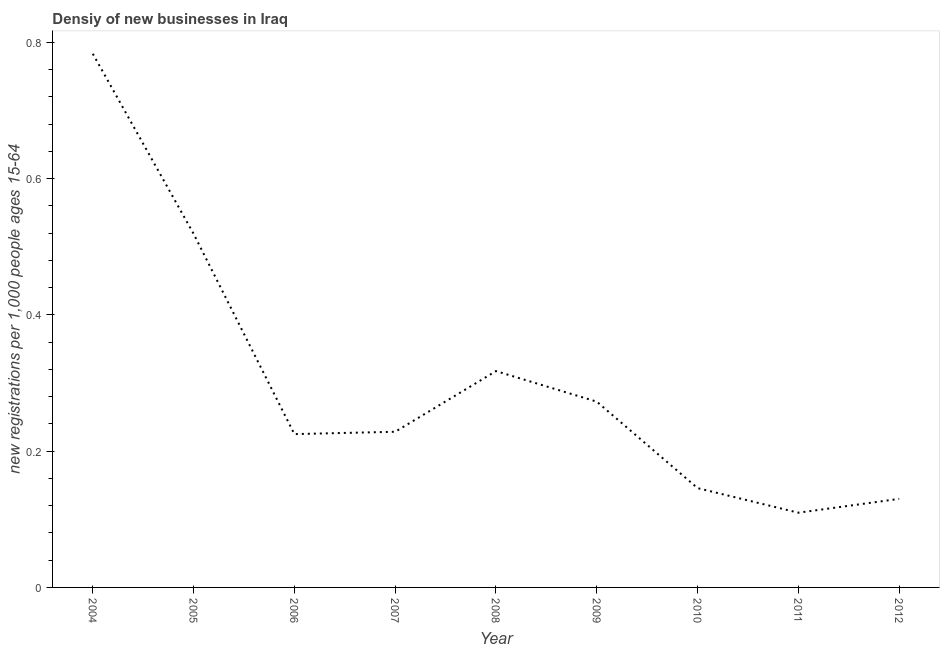What is the density of new business in 2008?
Offer a terse response. 0.32. Across all years, what is the maximum density of new business?
Provide a short and direct response. 0.78. Across all years, what is the minimum density of new business?
Your response must be concise. 0.11. In which year was the density of new business maximum?
Offer a terse response. 2004. What is the sum of the density of new business?
Your response must be concise. 2.73. What is the difference between the density of new business in 2004 and 2010?
Provide a short and direct response. 0.64. What is the average density of new business per year?
Offer a terse response. 0.3. What is the median density of new business?
Keep it short and to the point. 0.23. In how many years, is the density of new business greater than 0.4 ?
Your answer should be very brief. 2. Do a majority of the years between 2004 and 2007 (inclusive) have density of new business greater than 0.44 ?
Provide a succinct answer. No. What is the ratio of the density of new business in 2004 to that in 2005?
Offer a terse response. 1.51. Is the difference between the density of new business in 2005 and 2012 greater than the difference between any two years?
Offer a very short reply. No. What is the difference between the highest and the second highest density of new business?
Ensure brevity in your answer.  0.26. What is the difference between the highest and the lowest density of new business?
Keep it short and to the point. 0.67. In how many years, is the density of new business greater than the average density of new business taken over all years?
Give a very brief answer. 3. How many lines are there?
Your answer should be compact. 1. Are the values on the major ticks of Y-axis written in scientific E-notation?
Your answer should be compact. No. Does the graph contain any zero values?
Ensure brevity in your answer.  No. Does the graph contain grids?
Keep it short and to the point. No. What is the title of the graph?
Ensure brevity in your answer.  Densiy of new businesses in Iraq. What is the label or title of the Y-axis?
Ensure brevity in your answer.  New registrations per 1,0 people ages 15-64. What is the new registrations per 1,000 people ages 15-64 of 2004?
Your answer should be very brief. 0.78. What is the new registrations per 1,000 people ages 15-64 of 2005?
Give a very brief answer. 0.52. What is the new registrations per 1,000 people ages 15-64 of 2006?
Make the answer very short. 0.23. What is the new registrations per 1,000 people ages 15-64 in 2007?
Ensure brevity in your answer.  0.23. What is the new registrations per 1,000 people ages 15-64 of 2008?
Your response must be concise. 0.32. What is the new registrations per 1,000 people ages 15-64 of 2009?
Offer a terse response. 0.27. What is the new registrations per 1,000 people ages 15-64 of 2010?
Your response must be concise. 0.15. What is the new registrations per 1,000 people ages 15-64 of 2011?
Provide a short and direct response. 0.11. What is the new registrations per 1,000 people ages 15-64 of 2012?
Provide a short and direct response. 0.13. What is the difference between the new registrations per 1,000 people ages 15-64 in 2004 and 2005?
Make the answer very short. 0.26. What is the difference between the new registrations per 1,000 people ages 15-64 in 2004 and 2006?
Your answer should be compact. 0.56. What is the difference between the new registrations per 1,000 people ages 15-64 in 2004 and 2007?
Provide a succinct answer. 0.55. What is the difference between the new registrations per 1,000 people ages 15-64 in 2004 and 2008?
Your answer should be compact. 0.47. What is the difference between the new registrations per 1,000 people ages 15-64 in 2004 and 2009?
Your response must be concise. 0.51. What is the difference between the new registrations per 1,000 people ages 15-64 in 2004 and 2010?
Provide a succinct answer. 0.64. What is the difference between the new registrations per 1,000 people ages 15-64 in 2004 and 2011?
Provide a short and direct response. 0.67. What is the difference between the new registrations per 1,000 people ages 15-64 in 2004 and 2012?
Give a very brief answer. 0.65. What is the difference between the new registrations per 1,000 people ages 15-64 in 2005 and 2006?
Your answer should be very brief. 0.29. What is the difference between the new registrations per 1,000 people ages 15-64 in 2005 and 2007?
Ensure brevity in your answer.  0.29. What is the difference between the new registrations per 1,000 people ages 15-64 in 2005 and 2008?
Keep it short and to the point. 0.2. What is the difference between the new registrations per 1,000 people ages 15-64 in 2005 and 2009?
Ensure brevity in your answer.  0.25. What is the difference between the new registrations per 1,000 people ages 15-64 in 2005 and 2010?
Keep it short and to the point. 0.37. What is the difference between the new registrations per 1,000 people ages 15-64 in 2005 and 2011?
Make the answer very short. 0.41. What is the difference between the new registrations per 1,000 people ages 15-64 in 2005 and 2012?
Provide a succinct answer. 0.39. What is the difference between the new registrations per 1,000 people ages 15-64 in 2006 and 2007?
Offer a very short reply. -0. What is the difference between the new registrations per 1,000 people ages 15-64 in 2006 and 2008?
Your response must be concise. -0.09. What is the difference between the new registrations per 1,000 people ages 15-64 in 2006 and 2009?
Provide a short and direct response. -0.05. What is the difference between the new registrations per 1,000 people ages 15-64 in 2006 and 2010?
Ensure brevity in your answer.  0.08. What is the difference between the new registrations per 1,000 people ages 15-64 in 2006 and 2011?
Ensure brevity in your answer.  0.12. What is the difference between the new registrations per 1,000 people ages 15-64 in 2006 and 2012?
Give a very brief answer. 0.1. What is the difference between the new registrations per 1,000 people ages 15-64 in 2007 and 2008?
Your answer should be compact. -0.09. What is the difference between the new registrations per 1,000 people ages 15-64 in 2007 and 2009?
Your answer should be very brief. -0.04. What is the difference between the new registrations per 1,000 people ages 15-64 in 2007 and 2010?
Your response must be concise. 0.08. What is the difference between the new registrations per 1,000 people ages 15-64 in 2007 and 2011?
Ensure brevity in your answer.  0.12. What is the difference between the new registrations per 1,000 people ages 15-64 in 2007 and 2012?
Offer a terse response. 0.1. What is the difference between the new registrations per 1,000 people ages 15-64 in 2008 and 2009?
Provide a succinct answer. 0.04. What is the difference between the new registrations per 1,000 people ages 15-64 in 2008 and 2010?
Make the answer very short. 0.17. What is the difference between the new registrations per 1,000 people ages 15-64 in 2008 and 2011?
Ensure brevity in your answer.  0.21. What is the difference between the new registrations per 1,000 people ages 15-64 in 2008 and 2012?
Your response must be concise. 0.19. What is the difference between the new registrations per 1,000 people ages 15-64 in 2009 and 2010?
Your response must be concise. 0.13. What is the difference between the new registrations per 1,000 people ages 15-64 in 2009 and 2011?
Provide a short and direct response. 0.16. What is the difference between the new registrations per 1,000 people ages 15-64 in 2009 and 2012?
Give a very brief answer. 0.14. What is the difference between the new registrations per 1,000 people ages 15-64 in 2010 and 2011?
Offer a terse response. 0.04. What is the difference between the new registrations per 1,000 people ages 15-64 in 2010 and 2012?
Ensure brevity in your answer.  0.02. What is the difference between the new registrations per 1,000 people ages 15-64 in 2011 and 2012?
Keep it short and to the point. -0.02. What is the ratio of the new registrations per 1,000 people ages 15-64 in 2004 to that in 2005?
Your response must be concise. 1.51. What is the ratio of the new registrations per 1,000 people ages 15-64 in 2004 to that in 2006?
Make the answer very short. 3.48. What is the ratio of the new registrations per 1,000 people ages 15-64 in 2004 to that in 2007?
Your answer should be very brief. 3.43. What is the ratio of the new registrations per 1,000 people ages 15-64 in 2004 to that in 2008?
Give a very brief answer. 2.47. What is the ratio of the new registrations per 1,000 people ages 15-64 in 2004 to that in 2009?
Make the answer very short. 2.87. What is the ratio of the new registrations per 1,000 people ages 15-64 in 2004 to that in 2010?
Your answer should be compact. 5.38. What is the ratio of the new registrations per 1,000 people ages 15-64 in 2004 to that in 2011?
Your answer should be very brief. 7.14. What is the ratio of the new registrations per 1,000 people ages 15-64 in 2004 to that in 2012?
Keep it short and to the point. 6.03. What is the ratio of the new registrations per 1,000 people ages 15-64 in 2005 to that in 2006?
Keep it short and to the point. 2.31. What is the ratio of the new registrations per 1,000 people ages 15-64 in 2005 to that in 2007?
Give a very brief answer. 2.27. What is the ratio of the new registrations per 1,000 people ages 15-64 in 2005 to that in 2008?
Make the answer very short. 1.64. What is the ratio of the new registrations per 1,000 people ages 15-64 in 2005 to that in 2009?
Ensure brevity in your answer.  1.9. What is the ratio of the new registrations per 1,000 people ages 15-64 in 2005 to that in 2010?
Make the answer very short. 3.56. What is the ratio of the new registrations per 1,000 people ages 15-64 in 2005 to that in 2011?
Give a very brief answer. 4.73. What is the ratio of the new registrations per 1,000 people ages 15-64 in 2005 to that in 2012?
Your response must be concise. 3.99. What is the ratio of the new registrations per 1,000 people ages 15-64 in 2006 to that in 2007?
Your answer should be very brief. 0.98. What is the ratio of the new registrations per 1,000 people ages 15-64 in 2006 to that in 2008?
Your response must be concise. 0.71. What is the ratio of the new registrations per 1,000 people ages 15-64 in 2006 to that in 2009?
Your response must be concise. 0.82. What is the ratio of the new registrations per 1,000 people ages 15-64 in 2006 to that in 2010?
Your answer should be very brief. 1.54. What is the ratio of the new registrations per 1,000 people ages 15-64 in 2006 to that in 2011?
Offer a very short reply. 2.05. What is the ratio of the new registrations per 1,000 people ages 15-64 in 2006 to that in 2012?
Ensure brevity in your answer.  1.73. What is the ratio of the new registrations per 1,000 people ages 15-64 in 2007 to that in 2008?
Keep it short and to the point. 0.72. What is the ratio of the new registrations per 1,000 people ages 15-64 in 2007 to that in 2009?
Offer a very short reply. 0.84. What is the ratio of the new registrations per 1,000 people ages 15-64 in 2007 to that in 2010?
Your answer should be compact. 1.57. What is the ratio of the new registrations per 1,000 people ages 15-64 in 2007 to that in 2011?
Your answer should be compact. 2.08. What is the ratio of the new registrations per 1,000 people ages 15-64 in 2007 to that in 2012?
Ensure brevity in your answer.  1.76. What is the ratio of the new registrations per 1,000 people ages 15-64 in 2008 to that in 2009?
Keep it short and to the point. 1.16. What is the ratio of the new registrations per 1,000 people ages 15-64 in 2008 to that in 2010?
Provide a short and direct response. 2.18. What is the ratio of the new registrations per 1,000 people ages 15-64 in 2008 to that in 2011?
Give a very brief answer. 2.9. What is the ratio of the new registrations per 1,000 people ages 15-64 in 2008 to that in 2012?
Your response must be concise. 2.44. What is the ratio of the new registrations per 1,000 people ages 15-64 in 2009 to that in 2010?
Your response must be concise. 1.87. What is the ratio of the new registrations per 1,000 people ages 15-64 in 2009 to that in 2011?
Ensure brevity in your answer.  2.49. What is the ratio of the new registrations per 1,000 people ages 15-64 in 2009 to that in 2012?
Provide a short and direct response. 2.1. What is the ratio of the new registrations per 1,000 people ages 15-64 in 2010 to that in 2011?
Provide a succinct answer. 1.33. What is the ratio of the new registrations per 1,000 people ages 15-64 in 2010 to that in 2012?
Provide a succinct answer. 1.12. What is the ratio of the new registrations per 1,000 people ages 15-64 in 2011 to that in 2012?
Ensure brevity in your answer.  0.84. 